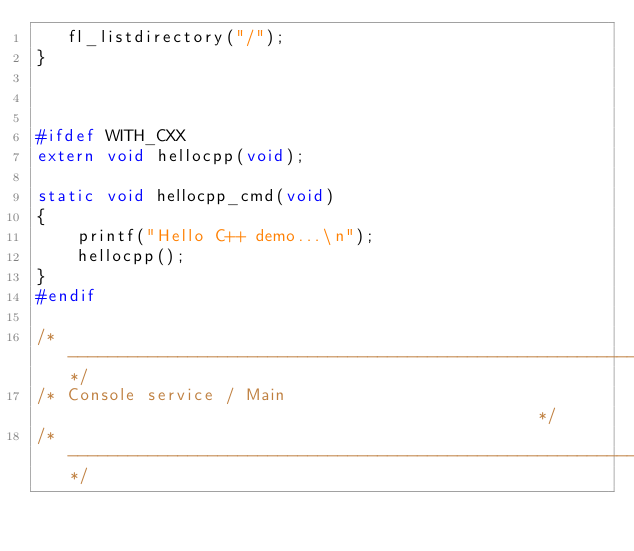<code> <loc_0><loc_0><loc_500><loc_500><_C_>   fl_listdirectory("/");
}



#ifdef WITH_CXX
extern void hellocpp(void);

static void hellocpp_cmd(void)
{
	printf("Hello C++ demo...\n");
	hellocpp();
}
#endif

/*-----------------------------------------------------------------------*/
/* Console service / Main                                                */
/*-----------------------------------------------------------------------*/
</code> 